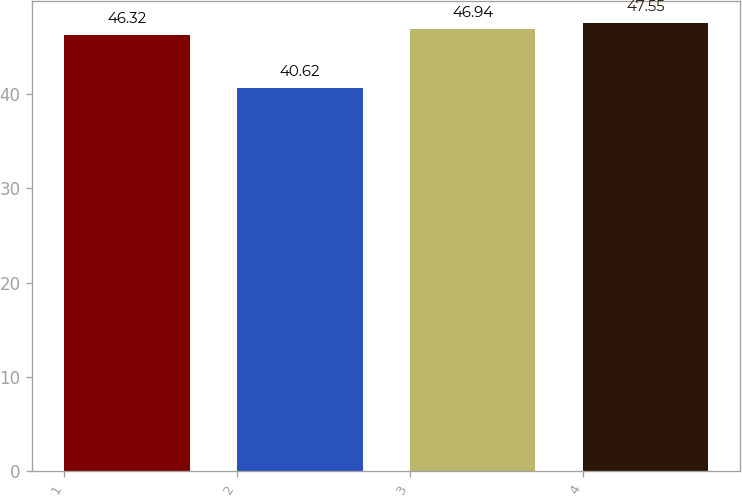Convert chart. <chart><loc_0><loc_0><loc_500><loc_500><bar_chart><fcel>1<fcel>2<fcel>3<fcel>4<nl><fcel>46.32<fcel>40.62<fcel>46.94<fcel>47.55<nl></chart> 